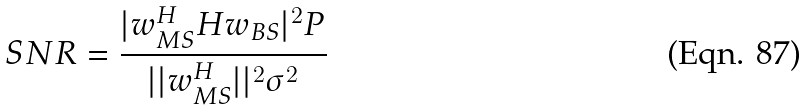Convert formula to latex. <formula><loc_0><loc_0><loc_500><loc_500>S N R = \frac { | w _ { M S } ^ { H } H w _ { B S } | ^ { 2 } P } { | | w _ { M S } ^ { H } | | ^ { 2 } \sigma ^ { 2 } }</formula> 